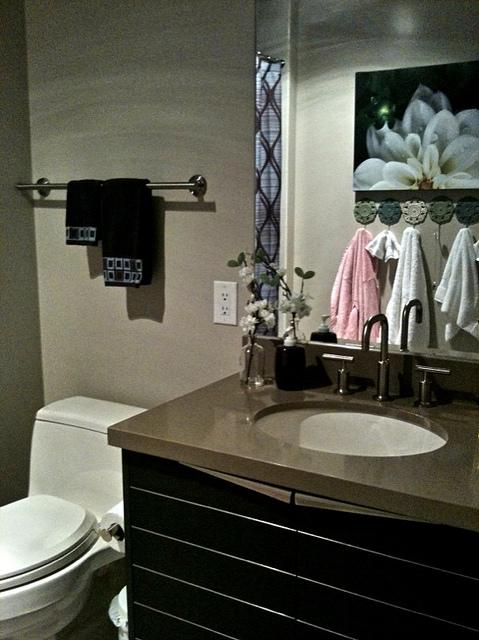What is likely opposite the toilet? Please explain your reasoning. bathtub. Bathtubs are normally in the bathroom. 